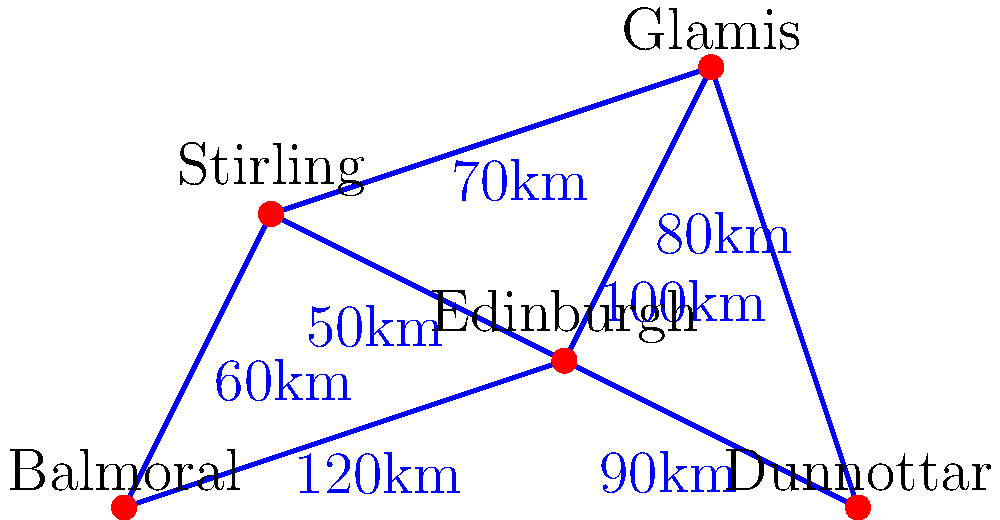As a tour guide planning a route for Queen Victoria's visit, what is the shortest path from Balmoral Castle to Dunnottar Castle, and what is its total distance? To find the shortest path from Balmoral Castle to Dunnottar Castle, we'll use Dijkstra's algorithm:

1. Start at Balmoral Castle (distance = 0 km)
2. Examine neighbors:
   - Stirling: 60 km
   - Edinburgh: 120 km
3. Choose Stirling (60 km)
4. From Stirling, examine:
   - Edinburgh: 60 + 50 = 110 km
   - Glamis: 60 + 70 = 130 km
5. Choose Edinburgh (110 km)
6. From Edinburgh, examine:
   - Glamis: 110 + 80 = 190 km
   - Dunnottar: 110 + 90 = 200 km
7. Choose Dunnottar (200 km)

The shortest path is Balmoral → Stirling → Edinburgh → Dunnottar.
Total distance: $60 + 50 + 90 = 200$ km
Answer: Balmoral → Stirling → Edinburgh → Dunnottar, 200 km 